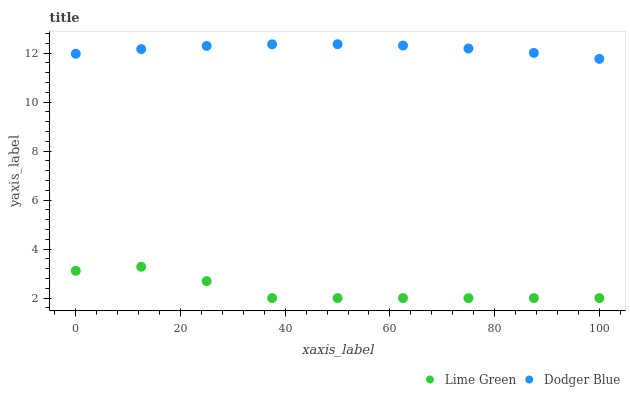Does Lime Green have the minimum area under the curve?
Answer yes or no. Yes. Does Dodger Blue have the maximum area under the curve?
Answer yes or no. Yes. Does Lime Green have the maximum area under the curve?
Answer yes or no. No. Is Dodger Blue the smoothest?
Answer yes or no. Yes. Is Lime Green the roughest?
Answer yes or no. Yes. Is Lime Green the smoothest?
Answer yes or no. No. Does Lime Green have the lowest value?
Answer yes or no. Yes. Does Dodger Blue have the highest value?
Answer yes or no. Yes. Does Lime Green have the highest value?
Answer yes or no. No. Is Lime Green less than Dodger Blue?
Answer yes or no. Yes. Is Dodger Blue greater than Lime Green?
Answer yes or no. Yes. Does Lime Green intersect Dodger Blue?
Answer yes or no. No. 